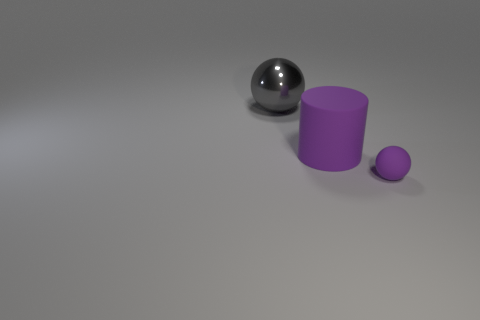Add 3 large gray shiny cylinders. How many objects exist? 6 Subtract all spheres. How many objects are left? 1 Add 1 large metal balls. How many large metal balls exist? 2 Subtract 1 purple cylinders. How many objects are left? 2 Subtract all balls. Subtract all purple spheres. How many objects are left? 0 Add 3 spheres. How many spheres are left? 5 